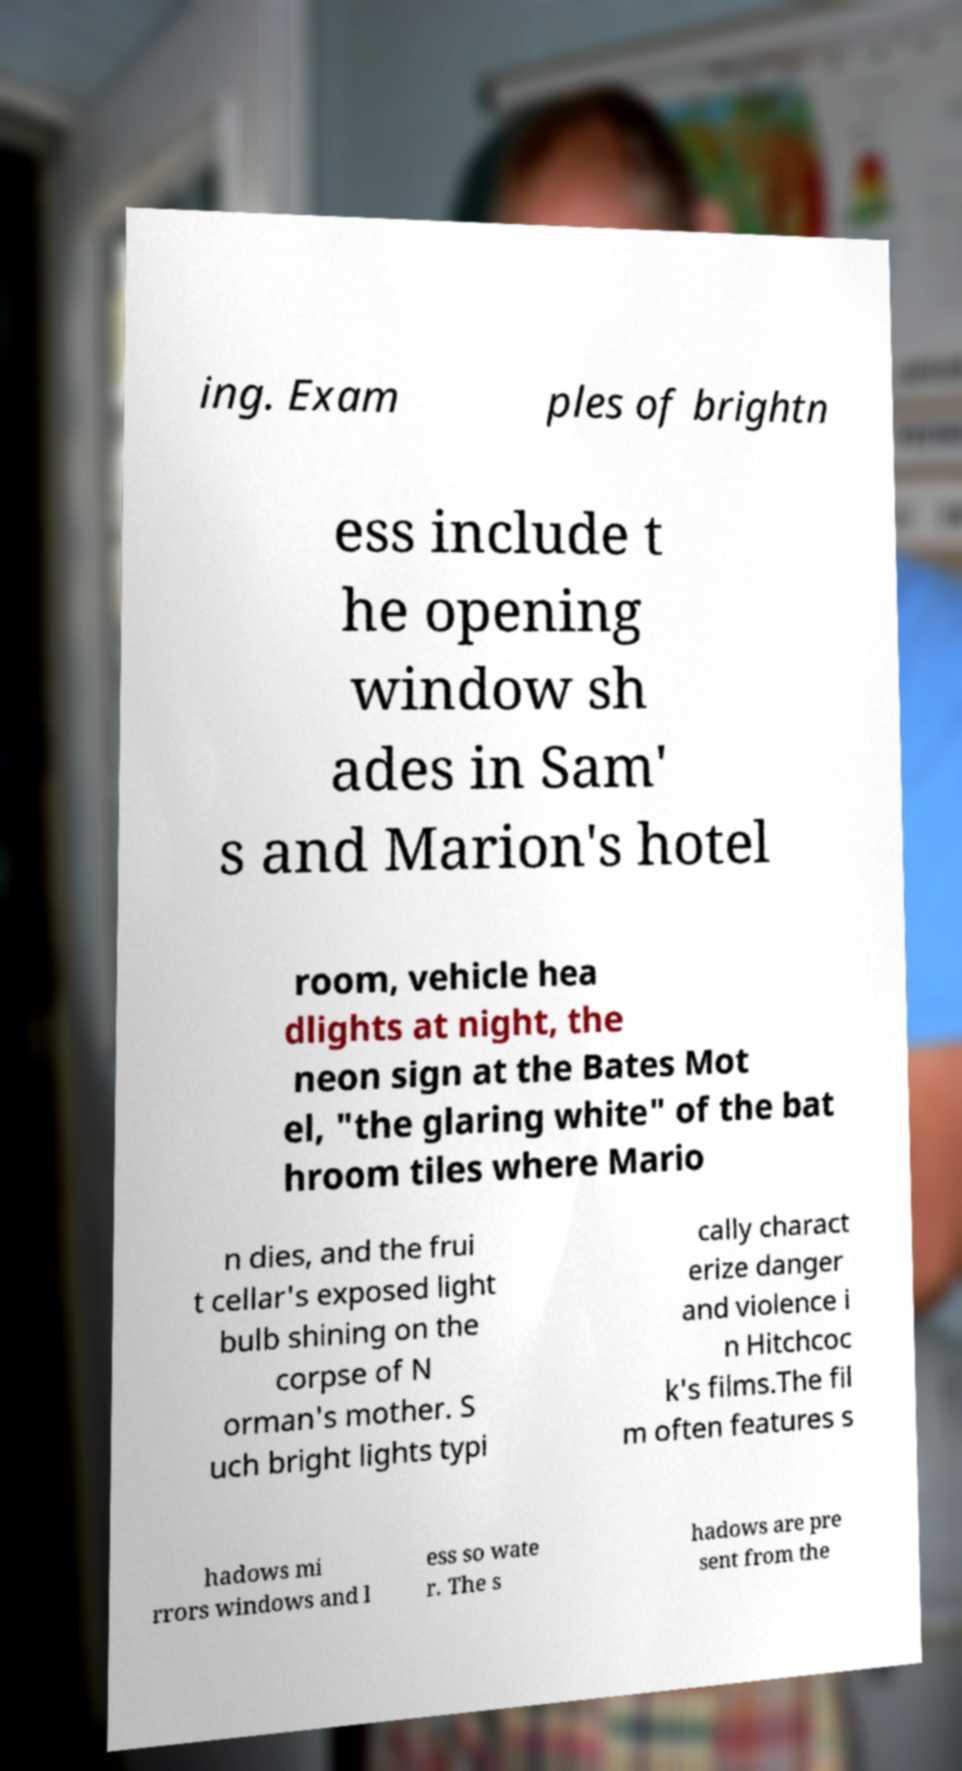Can you read and provide the text displayed in the image?This photo seems to have some interesting text. Can you extract and type it out for me? ing. Exam ples of brightn ess include t he opening window sh ades in Sam' s and Marion's hotel room, vehicle hea dlights at night, the neon sign at the Bates Mot el, "the glaring white" of the bat hroom tiles where Mario n dies, and the frui t cellar's exposed light bulb shining on the corpse of N orman's mother. S uch bright lights typi cally charact erize danger and violence i n Hitchcoc k's films.The fil m often features s hadows mi rrors windows and l ess so wate r. The s hadows are pre sent from the 